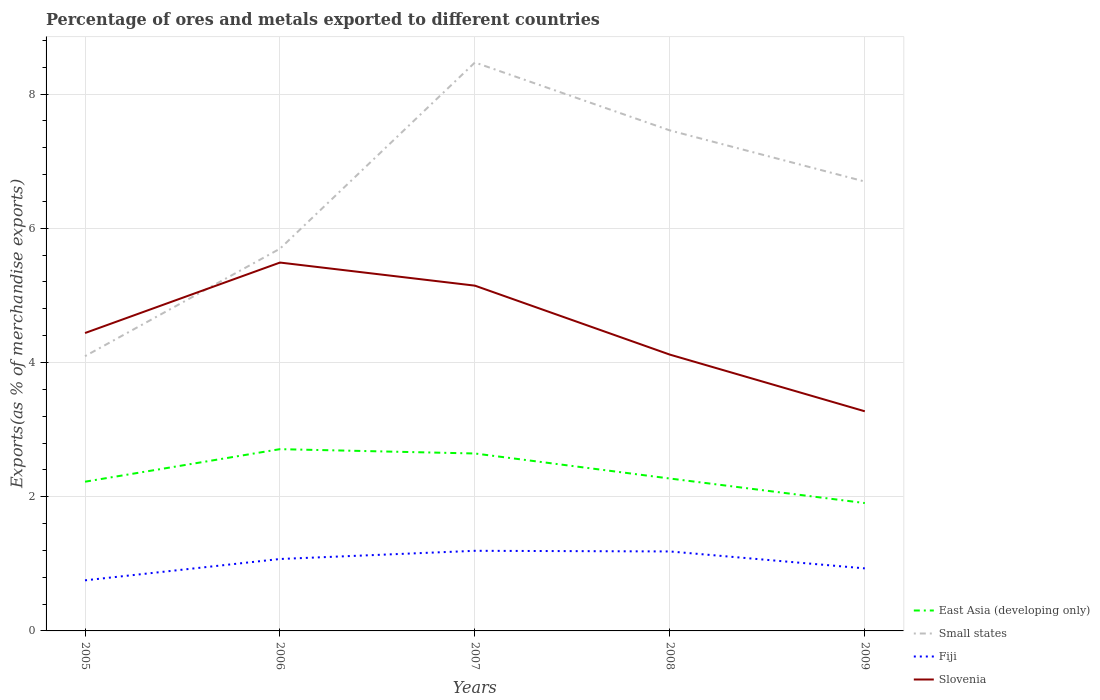How many different coloured lines are there?
Provide a succinct answer. 4. Across all years, what is the maximum percentage of exports to different countries in Small states?
Offer a very short reply. 4.09. In which year was the percentage of exports to different countries in Slovenia maximum?
Give a very brief answer. 2009. What is the total percentage of exports to different countries in Slovenia in the graph?
Keep it short and to the point. -1.05. What is the difference between the highest and the second highest percentage of exports to different countries in East Asia (developing only)?
Give a very brief answer. 0.8. What is the difference between the highest and the lowest percentage of exports to different countries in Slovenia?
Your answer should be very brief. 2. How many lines are there?
Your response must be concise. 4. What is the difference between two consecutive major ticks on the Y-axis?
Provide a short and direct response. 2. Are the values on the major ticks of Y-axis written in scientific E-notation?
Keep it short and to the point. No. Does the graph contain any zero values?
Your answer should be compact. No. Where does the legend appear in the graph?
Provide a succinct answer. Bottom right. How are the legend labels stacked?
Give a very brief answer. Vertical. What is the title of the graph?
Keep it short and to the point. Percentage of ores and metals exported to different countries. What is the label or title of the X-axis?
Give a very brief answer. Years. What is the label or title of the Y-axis?
Provide a short and direct response. Exports(as % of merchandise exports). What is the Exports(as % of merchandise exports) of East Asia (developing only) in 2005?
Keep it short and to the point. 2.22. What is the Exports(as % of merchandise exports) of Small states in 2005?
Provide a short and direct response. 4.09. What is the Exports(as % of merchandise exports) of Fiji in 2005?
Ensure brevity in your answer.  0.75. What is the Exports(as % of merchandise exports) in Slovenia in 2005?
Make the answer very short. 4.44. What is the Exports(as % of merchandise exports) of East Asia (developing only) in 2006?
Make the answer very short. 2.71. What is the Exports(as % of merchandise exports) in Small states in 2006?
Ensure brevity in your answer.  5.7. What is the Exports(as % of merchandise exports) of Fiji in 2006?
Your answer should be very brief. 1.07. What is the Exports(as % of merchandise exports) of Slovenia in 2006?
Offer a very short reply. 5.49. What is the Exports(as % of merchandise exports) of East Asia (developing only) in 2007?
Your response must be concise. 2.64. What is the Exports(as % of merchandise exports) in Small states in 2007?
Make the answer very short. 8.47. What is the Exports(as % of merchandise exports) in Fiji in 2007?
Your response must be concise. 1.19. What is the Exports(as % of merchandise exports) in Slovenia in 2007?
Keep it short and to the point. 5.14. What is the Exports(as % of merchandise exports) of East Asia (developing only) in 2008?
Offer a very short reply. 2.27. What is the Exports(as % of merchandise exports) in Small states in 2008?
Give a very brief answer. 7.46. What is the Exports(as % of merchandise exports) in Fiji in 2008?
Your response must be concise. 1.18. What is the Exports(as % of merchandise exports) in Slovenia in 2008?
Provide a succinct answer. 4.12. What is the Exports(as % of merchandise exports) in East Asia (developing only) in 2009?
Ensure brevity in your answer.  1.91. What is the Exports(as % of merchandise exports) of Small states in 2009?
Provide a short and direct response. 6.7. What is the Exports(as % of merchandise exports) of Fiji in 2009?
Your response must be concise. 0.93. What is the Exports(as % of merchandise exports) of Slovenia in 2009?
Provide a short and direct response. 3.27. Across all years, what is the maximum Exports(as % of merchandise exports) of East Asia (developing only)?
Make the answer very short. 2.71. Across all years, what is the maximum Exports(as % of merchandise exports) of Small states?
Provide a short and direct response. 8.47. Across all years, what is the maximum Exports(as % of merchandise exports) in Fiji?
Provide a succinct answer. 1.19. Across all years, what is the maximum Exports(as % of merchandise exports) in Slovenia?
Offer a terse response. 5.49. Across all years, what is the minimum Exports(as % of merchandise exports) of East Asia (developing only)?
Offer a very short reply. 1.91. Across all years, what is the minimum Exports(as % of merchandise exports) of Small states?
Provide a succinct answer. 4.09. Across all years, what is the minimum Exports(as % of merchandise exports) of Fiji?
Provide a short and direct response. 0.75. Across all years, what is the minimum Exports(as % of merchandise exports) in Slovenia?
Offer a very short reply. 3.27. What is the total Exports(as % of merchandise exports) in East Asia (developing only) in the graph?
Provide a short and direct response. 11.75. What is the total Exports(as % of merchandise exports) in Small states in the graph?
Your answer should be very brief. 32.41. What is the total Exports(as % of merchandise exports) in Fiji in the graph?
Provide a succinct answer. 5.14. What is the total Exports(as % of merchandise exports) in Slovenia in the graph?
Make the answer very short. 22.46. What is the difference between the Exports(as % of merchandise exports) of East Asia (developing only) in 2005 and that in 2006?
Provide a short and direct response. -0.48. What is the difference between the Exports(as % of merchandise exports) of Small states in 2005 and that in 2006?
Your answer should be very brief. -1.6. What is the difference between the Exports(as % of merchandise exports) in Fiji in 2005 and that in 2006?
Give a very brief answer. -0.32. What is the difference between the Exports(as % of merchandise exports) in Slovenia in 2005 and that in 2006?
Offer a very short reply. -1.05. What is the difference between the Exports(as % of merchandise exports) in East Asia (developing only) in 2005 and that in 2007?
Offer a very short reply. -0.42. What is the difference between the Exports(as % of merchandise exports) in Small states in 2005 and that in 2007?
Provide a succinct answer. -4.38. What is the difference between the Exports(as % of merchandise exports) in Fiji in 2005 and that in 2007?
Offer a very short reply. -0.44. What is the difference between the Exports(as % of merchandise exports) in Slovenia in 2005 and that in 2007?
Provide a succinct answer. -0.71. What is the difference between the Exports(as % of merchandise exports) of East Asia (developing only) in 2005 and that in 2008?
Make the answer very short. -0.05. What is the difference between the Exports(as % of merchandise exports) of Small states in 2005 and that in 2008?
Offer a terse response. -3.36. What is the difference between the Exports(as % of merchandise exports) in Fiji in 2005 and that in 2008?
Your answer should be very brief. -0.43. What is the difference between the Exports(as % of merchandise exports) in Slovenia in 2005 and that in 2008?
Offer a very short reply. 0.32. What is the difference between the Exports(as % of merchandise exports) in East Asia (developing only) in 2005 and that in 2009?
Make the answer very short. 0.32. What is the difference between the Exports(as % of merchandise exports) of Small states in 2005 and that in 2009?
Provide a short and direct response. -2.6. What is the difference between the Exports(as % of merchandise exports) of Fiji in 2005 and that in 2009?
Keep it short and to the point. -0.18. What is the difference between the Exports(as % of merchandise exports) of Slovenia in 2005 and that in 2009?
Make the answer very short. 1.17. What is the difference between the Exports(as % of merchandise exports) of East Asia (developing only) in 2006 and that in 2007?
Give a very brief answer. 0.06. What is the difference between the Exports(as % of merchandise exports) in Small states in 2006 and that in 2007?
Give a very brief answer. -2.77. What is the difference between the Exports(as % of merchandise exports) in Fiji in 2006 and that in 2007?
Offer a terse response. -0.12. What is the difference between the Exports(as % of merchandise exports) in Slovenia in 2006 and that in 2007?
Give a very brief answer. 0.34. What is the difference between the Exports(as % of merchandise exports) in East Asia (developing only) in 2006 and that in 2008?
Keep it short and to the point. 0.44. What is the difference between the Exports(as % of merchandise exports) of Small states in 2006 and that in 2008?
Make the answer very short. -1.76. What is the difference between the Exports(as % of merchandise exports) of Fiji in 2006 and that in 2008?
Give a very brief answer. -0.11. What is the difference between the Exports(as % of merchandise exports) of Slovenia in 2006 and that in 2008?
Keep it short and to the point. 1.37. What is the difference between the Exports(as % of merchandise exports) in East Asia (developing only) in 2006 and that in 2009?
Offer a terse response. 0.8. What is the difference between the Exports(as % of merchandise exports) of Small states in 2006 and that in 2009?
Give a very brief answer. -1. What is the difference between the Exports(as % of merchandise exports) in Fiji in 2006 and that in 2009?
Your answer should be compact. 0.14. What is the difference between the Exports(as % of merchandise exports) of Slovenia in 2006 and that in 2009?
Ensure brevity in your answer.  2.22. What is the difference between the Exports(as % of merchandise exports) of East Asia (developing only) in 2007 and that in 2008?
Your answer should be compact. 0.37. What is the difference between the Exports(as % of merchandise exports) in Small states in 2007 and that in 2008?
Offer a terse response. 1.01. What is the difference between the Exports(as % of merchandise exports) of Fiji in 2007 and that in 2008?
Give a very brief answer. 0.01. What is the difference between the Exports(as % of merchandise exports) of Slovenia in 2007 and that in 2008?
Keep it short and to the point. 1.03. What is the difference between the Exports(as % of merchandise exports) of East Asia (developing only) in 2007 and that in 2009?
Ensure brevity in your answer.  0.74. What is the difference between the Exports(as % of merchandise exports) of Small states in 2007 and that in 2009?
Your response must be concise. 1.77. What is the difference between the Exports(as % of merchandise exports) of Fiji in 2007 and that in 2009?
Keep it short and to the point. 0.26. What is the difference between the Exports(as % of merchandise exports) of Slovenia in 2007 and that in 2009?
Offer a very short reply. 1.87. What is the difference between the Exports(as % of merchandise exports) of East Asia (developing only) in 2008 and that in 2009?
Ensure brevity in your answer.  0.37. What is the difference between the Exports(as % of merchandise exports) in Small states in 2008 and that in 2009?
Provide a succinct answer. 0.76. What is the difference between the Exports(as % of merchandise exports) of Fiji in 2008 and that in 2009?
Offer a terse response. 0.25. What is the difference between the Exports(as % of merchandise exports) in Slovenia in 2008 and that in 2009?
Offer a terse response. 0.84. What is the difference between the Exports(as % of merchandise exports) in East Asia (developing only) in 2005 and the Exports(as % of merchandise exports) in Small states in 2006?
Your answer should be compact. -3.47. What is the difference between the Exports(as % of merchandise exports) of East Asia (developing only) in 2005 and the Exports(as % of merchandise exports) of Fiji in 2006?
Offer a very short reply. 1.15. What is the difference between the Exports(as % of merchandise exports) of East Asia (developing only) in 2005 and the Exports(as % of merchandise exports) of Slovenia in 2006?
Ensure brevity in your answer.  -3.27. What is the difference between the Exports(as % of merchandise exports) in Small states in 2005 and the Exports(as % of merchandise exports) in Fiji in 2006?
Ensure brevity in your answer.  3.02. What is the difference between the Exports(as % of merchandise exports) of Small states in 2005 and the Exports(as % of merchandise exports) of Slovenia in 2006?
Provide a short and direct response. -1.39. What is the difference between the Exports(as % of merchandise exports) in Fiji in 2005 and the Exports(as % of merchandise exports) in Slovenia in 2006?
Provide a short and direct response. -4.73. What is the difference between the Exports(as % of merchandise exports) of East Asia (developing only) in 2005 and the Exports(as % of merchandise exports) of Small states in 2007?
Offer a terse response. -6.25. What is the difference between the Exports(as % of merchandise exports) in East Asia (developing only) in 2005 and the Exports(as % of merchandise exports) in Fiji in 2007?
Ensure brevity in your answer.  1.03. What is the difference between the Exports(as % of merchandise exports) in East Asia (developing only) in 2005 and the Exports(as % of merchandise exports) in Slovenia in 2007?
Offer a terse response. -2.92. What is the difference between the Exports(as % of merchandise exports) in Small states in 2005 and the Exports(as % of merchandise exports) in Fiji in 2007?
Give a very brief answer. 2.9. What is the difference between the Exports(as % of merchandise exports) of Small states in 2005 and the Exports(as % of merchandise exports) of Slovenia in 2007?
Keep it short and to the point. -1.05. What is the difference between the Exports(as % of merchandise exports) of Fiji in 2005 and the Exports(as % of merchandise exports) of Slovenia in 2007?
Ensure brevity in your answer.  -4.39. What is the difference between the Exports(as % of merchandise exports) in East Asia (developing only) in 2005 and the Exports(as % of merchandise exports) in Small states in 2008?
Your answer should be compact. -5.23. What is the difference between the Exports(as % of merchandise exports) of East Asia (developing only) in 2005 and the Exports(as % of merchandise exports) of Fiji in 2008?
Your answer should be compact. 1.04. What is the difference between the Exports(as % of merchandise exports) in East Asia (developing only) in 2005 and the Exports(as % of merchandise exports) in Slovenia in 2008?
Ensure brevity in your answer.  -1.89. What is the difference between the Exports(as % of merchandise exports) in Small states in 2005 and the Exports(as % of merchandise exports) in Fiji in 2008?
Your response must be concise. 2.91. What is the difference between the Exports(as % of merchandise exports) of Small states in 2005 and the Exports(as % of merchandise exports) of Slovenia in 2008?
Your answer should be compact. -0.02. What is the difference between the Exports(as % of merchandise exports) of Fiji in 2005 and the Exports(as % of merchandise exports) of Slovenia in 2008?
Your answer should be compact. -3.36. What is the difference between the Exports(as % of merchandise exports) of East Asia (developing only) in 2005 and the Exports(as % of merchandise exports) of Small states in 2009?
Provide a succinct answer. -4.47. What is the difference between the Exports(as % of merchandise exports) of East Asia (developing only) in 2005 and the Exports(as % of merchandise exports) of Fiji in 2009?
Ensure brevity in your answer.  1.29. What is the difference between the Exports(as % of merchandise exports) in East Asia (developing only) in 2005 and the Exports(as % of merchandise exports) in Slovenia in 2009?
Ensure brevity in your answer.  -1.05. What is the difference between the Exports(as % of merchandise exports) in Small states in 2005 and the Exports(as % of merchandise exports) in Fiji in 2009?
Provide a short and direct response. 3.16. What is the difference between the Exports(as % of merchandise exports) in Small states in 2005 and the Exports(as % of merchandise exports) in Slovenia in 2009?
Your response must be concise. 0.82. What is the difference between the Exports(as % of merchandise exports) in Fiji in 2005 and the Exports(as % of merchandise exports) in Slovenia in 2009?
Your answer should be very brief. -2.52. What is the difference between the Exports(as % of merchandise exports) of East Asia (developing only) in 2006 and the Exports(as % of merchandise exports) of Small states in 2007?
Make the answer very short. -5.76. What is the difference between the Exports(as % of merchandise exports) of East Asia (developing only) in 2006 and the Exports(as % of merchandise exports) of Fiji in 2007?
Offer a very short reply. 1.51. What is the difference between the Exports(as % of merchandise exports) of East Asia (developing only) in 2006 and the Exports(as % of merchandise exports) of Slovenia in 2007?
Provide a succinct answer. -2.44. What is the difference between the Exports(as % of merchandise exports) of Small states in 2006 and the Exports(as % of merchandise exports) of Fiji in 2007?
Your response must be concise. 4.5. What is the difference between the Exports(as % of merchandise exports) in Small states in 2006 and the Exports(as % of merchandise exports) in Slovenia in 2007?
Your response must be concise. 0.55. What is the difference between the Exports(as % of merchandise exports) in Fiji in 2006 and the Exports(as % of merchandise exports) in Slovenia in 2007?
Your response must be concise. -4.07. What is the difference between the Exports(as % of merchandise exports) in East Asia (developing only) in 2006 and the Exports(as % of merchandise exports) in Small states in 2008?
Offer a terse response. -4.75. What is the difference between the Exports(as % of merchandise exports) of East Asia (developing only) in 2006 and the Exports(as % of merchandise exports) of Fiji in 2008?
Your answer should be very brief. 1.52. What is the difference between the Exports(as % of merchandise exports) of East Asia (developing only) in 2006 and the Exports(as % of merchandise exports) of Slovenia in 2008?
Offer a terse response. -1.41. What is the difference between the Exports(as % of merchandise exports) of Small states in 2006 and the Exports(as % of merchandise exports) of Fiji in 2008?
Offer a terse response. 4.51. What is the difference between the Exports(as % of merchandise exports) of Small states in 2006 and the Exports(as % of merchandise exports) of Slovenia in 2008?
Offer a very short reply. 1.58. What is the difference between the Exports(as % of merchandise exports) in Fiji in 2006 and the Exports(as % of merchandise exports) in Slovenia in 2008?
Keep it short and to the point. -3.05. What is the difference between the Exports(as % of merchandise exports) in East Asia (developing only) in 2006 and the Exports(as % of merchandise exports) in Small states in 2009?
Your answer should be compact. -3.99. What is the difference between the Exports(as % of merchandise exports) in East Asia (developing only) in 2006 and the Exports(as % of merchandise exports) in Fiji in 2009?
Offer a terse response. 1.78. What is the difference between the Exports(as % of merchandise exports) in East Asia (developing only) in 2006 and the Exports(as % of merchandise exports) in Slovenia in 2009?
Provide a short and direct response. -0.56. What is the difference between the Exports(as % of merchandise exports) of Small states in 2006 and the Exports(as % of merchandise exports) of Fiji in 2009?
Keep it short and to the point. 4.76. What is the difference between the Exports(as % of merchandise exports) of Small states in 2006 and the Exports(as % of merchandise exports) of Slovenia in 2009?
Your answer should be very brief. 2.42. What is the difference between the Exports(as % of merchandise exports) in Fiji in 2006 and the Exports(as % of merchandise exports) in Slovenia in 2009?
Make the answer very short. -2.2. What is the difference between the Exports(as % of merchandise exports) of East Asia (developing only) in 2007 and the Exports(as % of merchandise exports) of Small states in 2008?
Your response must be concise. -4.81. What is the difference between the Exports(as % of merchandise exports) in East Asia (developing only) in 2007 and the Exports(as % of merchandise exports) in Fiji in 2008?
Offer a terse response. 1.46. What is the difference between the Exports(as % of merchandise exports) of East Asia (developing only) in 2007 and the Exports(as % of merchandise exports) of Slovenia in 2008?
Keep it short and to the point. -1.47. What is the difference between the Exports(as % of merchandise exports) of Small states in 2007 and the Exports(as % of merchandise exports) of Fiji in 2008?
Your answer should be compact. 7.29. What is the difference between the Exports(as % of merchandise exports) in Small states in 2007 and the Exports(as % of merchandise exports) in Slovenia in 2008?
Offer a terse response. 4.35. What is the difference between the Exports(as % of merchandise exports) in Fiji in 2007 and the Exports(as % of merchandise exports) in Slovenia in 2008?
Offer a very short reply. -2.92. What is the difference between the Exports(as % of merchandise exports) in East Asia (developing only) in 2007 and the Exports(as % of merchandise exports) in Small states in 2009?
Your response must be concise. -4.05. What is the difference between the Exports(as % of merchandise exports) in East Asia (developing only) in 2007 and the Exports(as % of merchandise exports) in Fiji in 2009?
Offer a very short reply. 1.71. What is the difference between the Exports(as % of merchandise exports) of East Asia (developing only) in 2007 and the Exports(as % of merchandise exports) of Slovenia in 2009?
Offer a terse response. -0.63. What is the difference between the Exports(as % of merchandise exports) in Small states in 2007 and the Exports(as % of merchandise exports) in Fiji in 2009?
Ensure brevity in your answer.  7.54. What is the difference between the Exports(as % of merchandise exports) in Small states in 2007 and the Exports(as % of merchandise exports) in Slovenia in 2009?
Your answer should be compact. 5.2. What is the difference between the Exports(as % of merchandise exports) of Fiji in 2007 and the Exports(as % of merchandise exports) of Slovenia in 2009?
Your answer should be compact. -2.08. What is the difference between the Exports(as % of merchandise exports) in East Asia (developing only) in 2008 and the Exports(as % of merchandise exports) in Small states in 2009?
Keep it short and to the point. -4.42. What is the difference between the Exports(as % of merchandise exports) of East Asia (developing only) in 2008 and the Exports(as % of merchandise exports) of Fiji in 2009?
Offer a terse response. 1.34. What is the difference between the Exports(as % of merchandise exports) of East Asia (developing only) in 2008 and the Exports(as % of merchandise exports) of Slovenia in 2009?
Offer a terse response. -1. What is the difference between the Exports(as % of merchandise exports) in Small states in 2008 and the Exports(as % of merchandise exports) in Fiji in 2009?
Make the answer very short. 6.53. What is the difference between the Exports(as % of merchandise exports) of Small states in 2008 and the Exports(as % of merchandise exports) of Slovenia in 2009?
Your response must be concise. 4.19. What is the difference between the Exports(as % of merchandise exports) in Fiji in 2008 and the Exports(as % of merchandise exports) in Slovenia in 2009?
Give a very brief answer. -2.09. What is the average Exports(as % of merchandise exports) in East Asia (developing only) per year?
Your response must be concise. 2.35. What is the average Exports(as % of merchandise exports) in Small states per year?
Your answer should be compact. 6.48. What is the average Exports(as % of merchandise exports) of Fiji per year?
Your answer should be compact. 1.03. What is the average Exports(as % of merchandise exports) in Slovenia per year?
Offer a terse response. 4.49. In the year 2005, what is the difference between the Exports(as % of merchandise exports) in East Asia (developing only) and Exports(as % of merchandise exports) in Small states?
Make the answer very short. -1.87. In the year 2005, what is the difference between the Exports(as % of merchandise exports) of East Asia (developing only) and Exports(as % of merchandise exports) of Fiji?
Provide a succinct answer. 1.47. In the year 2005, what is the difference between the Exports(as % of merchandise exports) in East Asia (developing only) and Exports(as % of merchandise exports) in Slovenia?
Your answer should be very brief. -2.22. In the year 2005, what is the difference between the Exports(as % of merchandise exports) of Small states and Exports(as % of merchandise exports) of Fiji?
Ensure brevity in your answer.  3.34. In the year 2005, what is the difference between the Exports(as % of merchandise exports) of Small states and Exports(as % of merchandise exports) of Slovenia?
Make the answer very short. -0.34. In the year 2005, what is the difference between the Exports(as % of merchandise exports) in Fiji and Exports(as % of merchandise exports) in Slovenia?
Make the answer very short. -3.68. In the year 2006, what is the difference between the Exports(as % of merchandise exports) in East Asia (developing only) and Exports(as % of merchandise exports) in Small states?
Offer a terse response. -2.99. In the year 2006, what is the difference between the Exports(as % of merchandise exports) of East Asia (developing only) and Exports(as % of merchandise exports) of Fiji?
Keep it short and to the point. 1.64. In the year 2006, what is the difference between the Exports(as % of merchandise exports) of East Asia (developing only) and Exports(as % of merchandise exports) of Slovenia?
Give a very brief answer. -2.78. In the year 2006, what is the difference between the Exports(as % of merchandise exports) of Small states and Exports(as % of merchandise exports) of Fiji?
Your answer should be very brief. 4.62. In the year 2006, what is the difference between the Exports(as % of merchandise exports) in Small states and Exports(as % of merchandise exports) in Slovenia?
Provide a short and direct response. 0.21. In the year 2006, what is the difference between the Exports(as % of merchandise exports) of Fiji and Exports(as % of merchandise exports) of Slovenia?
Your response must be concise. -4.42. In the year 2007, what is the difference between the Exports(as % of merchandise exports) of East Asia (developing only) and Exports(as % of merchandise exports) of Small states?
Provide a succinct answer. -5.83. In the year 2007, what is the difference between the Exports(as % of merchandise exports) in East Asia (developing only) and Exports(as % of merchandise exports) in Fiji?
Provide a succinct answer. 1.45. In the year 2007, what is the difference between the Exports(as % of merchandise exports) of East Asia (developing only) and Exports(as % of merchandise exports) of Slovenia?
Offer a terse response. -2.5. In the year 2007, what is the difference between the Exports(as % of merchandise exports) of Small states and Exports(as % of merchandise exports) of Fiji?
Provide a short and direct response. 7.28. In the year 2007, what is the difference between the Exports(as % of merchandise exports) in Small states and Exports(as % of merchandise exports) in Slovenia?
Keep it short and to the point. 3.33. In the year 2007, what is the difference between the Exports(as % of merchandise exports) of Fiji and Exports(as % of merchandise exports) of Slovenia?
Offer a very short reply. -3.95. In the year 2008, what is the difference between the Exports(as % of merchandise exports) in East Asia (developing only) and Exports(as % of merchandise exports) in Small states?
Provide a succinct answer. -5.19. In the year 2008, what is the difference between the Exports(as % of merchandise exports) in East Asia (developing only) and Exports(as % of merchandise exports) in Fiji?
Ensure brevity in your answer.  1.09. In the year 2008, what is the difference between the Exports(as % of merchandise exports) in East Asia (developing only) and Exports(as % of merchandise exports) in Slovenia?
Offer a very short reply. -1.85. In the year 2008, what is the difference between the Exports(as % of merchandise exports) of Small states and Exports(as % of merchandise exports) of Fiji?
Offer a very short reply. 6.27. In the year 2008, what is the difference between the Exports(as % of merchandise exports) in Small states and Exports(as % of merchandise exports) in Slovenia?
Ensure brevity in your answer.  3.34. In the year 2008, what is the difference between the Exports(as % of merchandise exports) of Fiji and Exports(as % of merchandise exports) of Slovenia?
Your answer should be very brief. -2.93. In the year 2009, what is the difference between the Exports(as % of merchandise exports) in East Asia (developing only) and Exports(as % of merchandise exports) in Small states?
Offer a terse response. -4.79. In the year 2009, what is the difference between the Exports(as % of merchandise exports) in East Asia (developing only) and Exports(as % of merchandise exports) in Fiji?
Give a very brief answer. 0.97. In the year 2009, what is the difference between the Exports(as % of merchandise exports) in East Asia (developing only) and Exports(as % of merchandise exports) in Slovenia?
Provide a succinct answer. -1.37. In the year 2009, what is the difference between the Exports(as % of merchandise exports) in Small states and Exports(as % of merchandise exports) in Fiji?
Your answer should be very brief. 5.76. In the year 2009, what is the difference between the Exports(as % of merchandise exports) in Small states and Exports(as % of merchandise exports) in Slovenia?
Provide a short and direct response. 3.42. In the year 2009, what is the difference between the Exports(as % of merchandise exports) in Fiji and Exports(as % of merchandise exports) in Slovenia?
Make the answer very short. -2.34. What is the ratio of the Exports(as % of merchandise exports) of East Asia (developing only) in 2005 to that in 2006?
Ensure brevity in your answer.  0.82. What is the ratio of the Exports(as % of merchandise exports) of Small states in 2005 to that in 2006?
Make the answer very short. 0.72. What is the ratio of the Exports(as % of merchandise exports) in Fiji in 2005 to that in 2006?
Make the answer very short. 0.7. What is the ratio of the Exports(as % of merchandise exports) of Slovenia in 2005 to that in 2006?
Your answer should be compact. 0.81. What is the ratio of the Exports(as % of merchandise exports) of East Asia (developing only) in 2005 to that in 2007?
Your response must be concise. 0.84. What is the ratio of the Exports(as % of merchandise exports) of Small states in 2005 to that in 2007?
Your response must be concise. 0.48. What is the ratio of the Exports(as % of merchandise exports) in Fiji in 2005 to that in 2007?
Offer a very short reply. 0.63. What is the ratio of the Exports(as % of merchandise exports) of Slovenia in 2005 to that in 2007?
Provide a short and direct response. 0.86. What is the ratio of the Exports(as % of merchandise exports) in East Asia (developing only) in 2005 to that in 2008?
Ensure brevity in your answer.  0.98. What is the ratio of the Exports(as % of merchandise exports) in Small states in 2005 to that in 2008?
Offer a terse response. 0.55. What is the ratio of the Exports(as % of merchandise exports) in Fiji in 2005 to that in 2008?
Offer a very short reply. 0.64. What is the ratio of the Exports(as % of merchandise exports) of Slovenia in 2005 to that in 2008?
Provide a succinct answer. 1.08. What is the ratio of the Exports(as % of merchandise exports) of East Asia (developing only) in 2005 to that in 2009?
Make the answer very short. 1.17. What is the ratio of the Exports(as % of merchandise exports) in Small states in 2005 to that in 2009?
Keep it short and to the point. 0.61. What is the ratio of the Exports(as % of merchandise exports) in Fiji in 2005 to that in 2009?
Your answer should be compact. 0.81. What is the ratio of the Exports(as % of merchandise exports) of Slovenia in 2005 to that in 2009?
Ensure brevity in your answer.  1.36. What is the ratio of the Exports(as % of merchandise exports) of East Asia (developing only) in 2006 to that in 2007?
Your answer should be very brief. 1.02. What is the ratio of the Exports(as % of merchandise exports) in Small states in 2006 to that in 2007?
Your response must be concise. 0.67. What is the ratio of the Exports(as % of merchandise exports) of Fiji in 2006 to that in 2007?
Make the answer very short. 0.9. What is the ratio of the Exports(as % of merchandise exports) in Slovenia in 2006 to that in 2007?
Offer a very short reply. 1.07. What is the ratio of the Exports(as % of merchandise exports) of East Asia (developing only) in 2006 to that in 2008?
Provide a succinct answer. 1.19. What is the ratio of the Exports(as % of merchandise exports) in Small states in 2006 to that in 2008?
Provide a succinct answer. 0.76. What is the ratio of the Exports(as % of merchandise exports) in Fiji in 2006 to that in 2008?
Offer a terse response. 0.91. What is the ratio of the Exports(as % of merchandise exports) in Slovenia in 2006 to that in 2008?
Offer a terse response. 1.33. What is the ratio of the Exports(as % of merchandise exports) of East Asia (developing only) in 2006 to that in 2009?
Give a very brief answer. 1.42. What is the ratio of the Exports(as % of merchandise exports) in Small states in 2006 to that in 2009?
Your response must be concise. 0.85. What is the ratio of the Exports(as % of merchandise exports) in Fiji in 2006 to that in 2009?
Your answer should be compact. 1.15. What is the ratio of the Exports(as % of merchandise exports) of Slovenia in 2006 to that in 2009?
Your response must be concise. 1.68. What is the ratio of the Exports(as % of merchandise exports) in East Asia (developing only) in 2007 to that in 2008?
Your answer should be compact. 1.16. What is the ratio of the Exports(as % of merchandise exports) of Small states in 2007 to that in 2008?
Offer a very short reply. 1.14. What is the ratio of the Exports(as % of merchandise exports) in Fiji in 2007 to that in 2008?
Your response must be concise. 1.01. What is the ratio of the Exports(as % of merchandise exports) in Slovenia in 2007 to that in 2008?
Offer a very short reply. 1.25. What is the ratio of the Exports(as % of merchandise exports) of East Asia (developing only) in 2007 to that in 2009?
Your response must be concise. 1.39. What is the ratio of the Exports(as % of merchandise exports) in Small states in 2007 to that in 2009?
Give a very brief answer. 1.26. What is the ratio of the Exports(as % of merchandise exports) of Fiji in 2007 to that in 2009?
Give a very brief answer. 1.28. What is the ratio of the Exports(as % of merchandise exports) in Slovenia in 2007 to that in 2009?
Provide a short and direct response. 1.57. What is the ratio of the Exports(as % of merchandise exports) in East Asia (developing only) in 2008 to that in 2009?
Offer a very short reply. 1.19. What is the ratio of the Exports(as % of merchandise exports) of Small states in 2008 to that in 2009?
Ensure brevity in your answer.  1.11. What is the ratio of the Exports(as % of merchandise exports) in Fiji in 2008 to that in 2009?
Provide a succinct answer. 1.27. What is the ratio of the Exports(as % of merchandise exports) of Slovenia in 2008 to that in 2009?
Your answer should be very brief. 1.26. What is the difference between the highest and the second highest Exports(as % of merchandise exports) of East Asia (developing only)?
Make the answer very short. 0.06. What is the difference between the highest and the second highest Exports(as % of merchandise exports) of Small states?
Keep it short and to the point. 1.01. What is the difference between the highest and the second highest Exports(as % of merchandise exports) of Fiji?
Provide a succinct answer. 0.01. What is the difference between the highest and the second highest Exports(as % of merchandise exports) of Slovenia?
Offer a very short reply. 0.34. What is the difference between the highest and the lowest Exports(as % of merchandise exports) in East Asia (developing only)?
Give a very brief answer. 0.8. What is the difference between the highest and the lowest Exports(as % of merchandise exports) in Small states?
Give a very brief answer. 4.38. What is the difference between the highest and the lowest Exports(as % of merchandise exports) in Fiji?
Ensure brevity in your answer.  0.44. What is the difference between the highest and the lowest Exports(as % of merchandise exports) in Slovenia?
Make the answer very short. 2.22. 